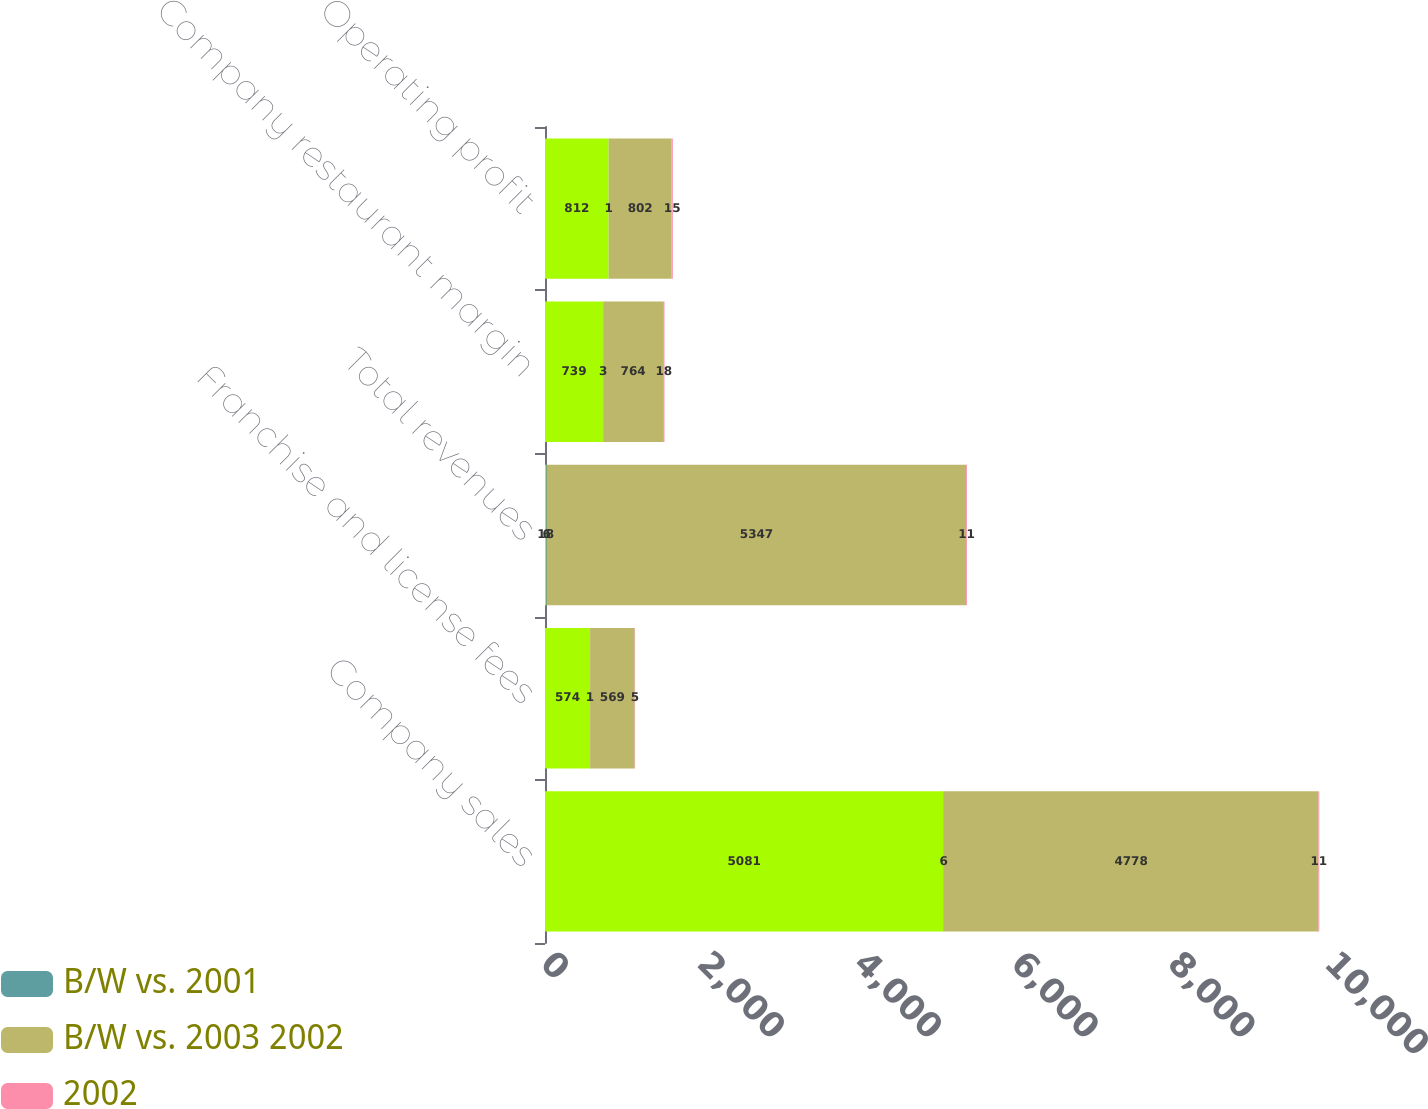<chart> <loc_0><loc_0><loc_500><loc_500><stacked_bar_chart><ecel><fcel>Company sales<fcel>Franchise and license fees<fcel>Total revenues<fcel>Company restaurant margin<fcel>Operating profit<nl><fcel>nan<fcel>5081<fcel>574<fcel>18<fcel>739<fcel>812<nl><fcel>B/W vs. 2001<fcel>6<fcel>1<fcel>6<fcel>3<fcel>1<nl><fcel>B/W vs. 2003 2002<fcel>4778<fcel>569<fcel>5347<fcel>764<fcel>802<nl><fcel>2002<fcel>11<fcel>5<fcel>11<fcel>18<fcel>15<nl></chart> 